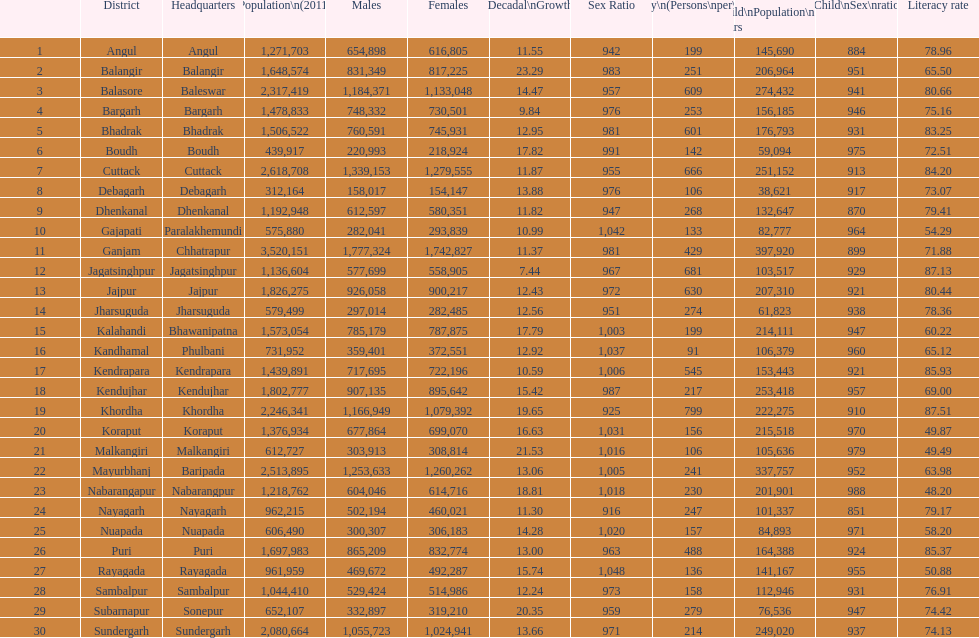Tell me a district that did not have a population over 600,000. Boudh. 